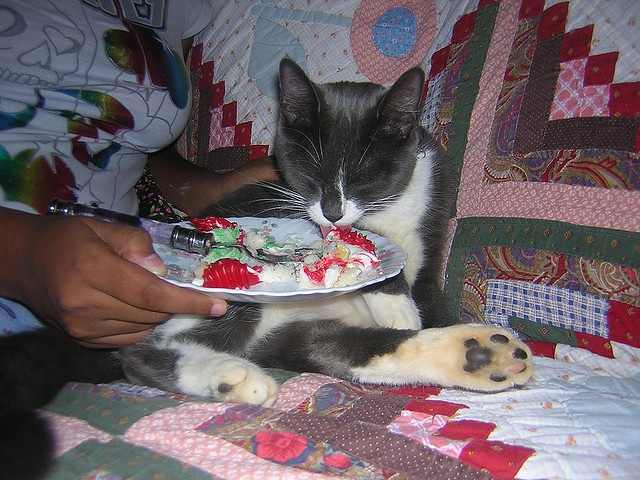Describe the objects in this image and their specific colors. I can see couch in black, gray, and darkgray tones, cat in black, gray, darkgray, and lightgray tones, people in black, gray, and maroon tones, cake in black, lightgray, darkgray, lightpink, and brown tones, and spoon in black, gray, and darkgray tones in this image. 